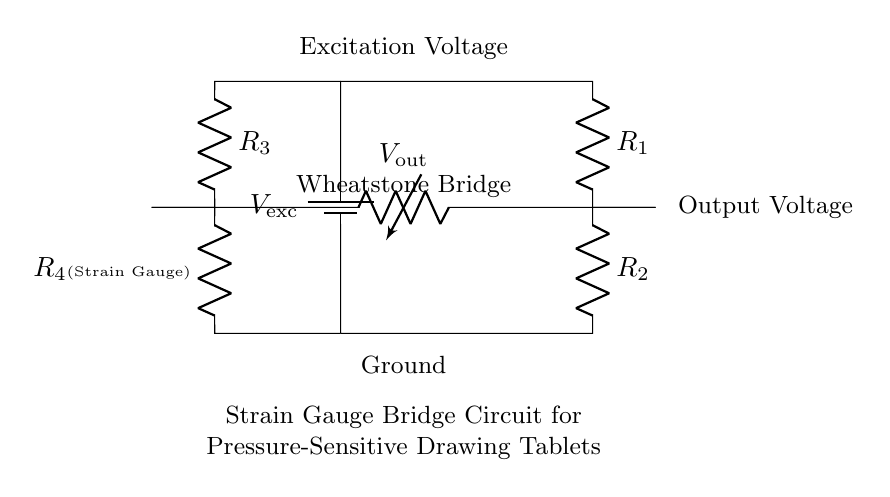What is the excitation voltage in this circuit? The circuit diagram labels the excitation voltage as "V_exc," indicating the supplied voltage to the Wheatstone bridge. However, the specific value is not provided in the diagram, leading to a conclusion that it remains unspecified.
Answer: unspecified What components make up the Wheatstone bridge? In the circuit, the Wheatstone bridge is identified by the arrangement of four resistors: R1, R2, R3, and R4. The diagram specifically indicates the strain gauge is connected as R4, highlighting its role within the bridge's balancing mechanism.
Answer: R1, R2, R3, R4 What is connected to the output voltage? The output voltage, labeled as "V_out," is connected between two points in the Wheatstone bridge, specifically at the junctions of R2 and R4. This point is crucial for determining the voltage change as pressure is applied to the strain gauge, affecting its resistance.
Answer: R2 and R4 How does this circuit detect pressure? The circuit detects pressure by using the strain gauge (R4), which changes resistance in response to applied pressure. In the Wheatstone bridge configuration, this change in resistance causes a voltage difference at V_out, which can be measured to determine the magnitude of the applied pressure.
Answer: By measuring voltage change What does the strain gauge represent in this circuit? The strain gauge is represented as R4 and is an essential component used to convert mechanical stress (pressure) into a change in resistance, which affects the output voltage of the Wheatstone bridge, allowing for the detection of the pressure applied by drawing.
Answer: R4 What happens if R4's resistance increases? If R4's resistance increases due to an increase in pressure, the balance of the Wheatstone bridge will be disturbed, leading to a change in the output voltage (V_out). This variation can be quantitatively measured to understand how much pressure has been applied to the drawing tablet.
Answer: Output voltage changes 